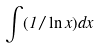<formula> <loc_0><loc_0><loc_500><loc_500>\int ( 1 / \ln x ) d x</formula> 